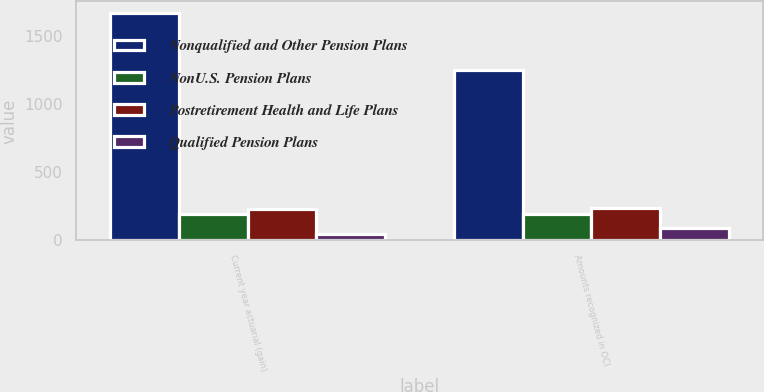<chart> <loc_0><loc_0><loc_500><loc_500><stacked_bar_chart><ecel><fcel>Current year actuarial (gain)<fcel>Amounts recognized in OCI<nl><fcel>Nonqualified and Other Pension Plans<fcel>1669<fcel>1251<nl><fcel>NonU.S. Pension Plans<fcel>192<fcel>190<nl><fcel>Postretirement Health and Life Plans<fcel>228<fcel>239<nl><fcel>Qualified Pension Plans<fcel>49<fcel>88<nl></chart> 